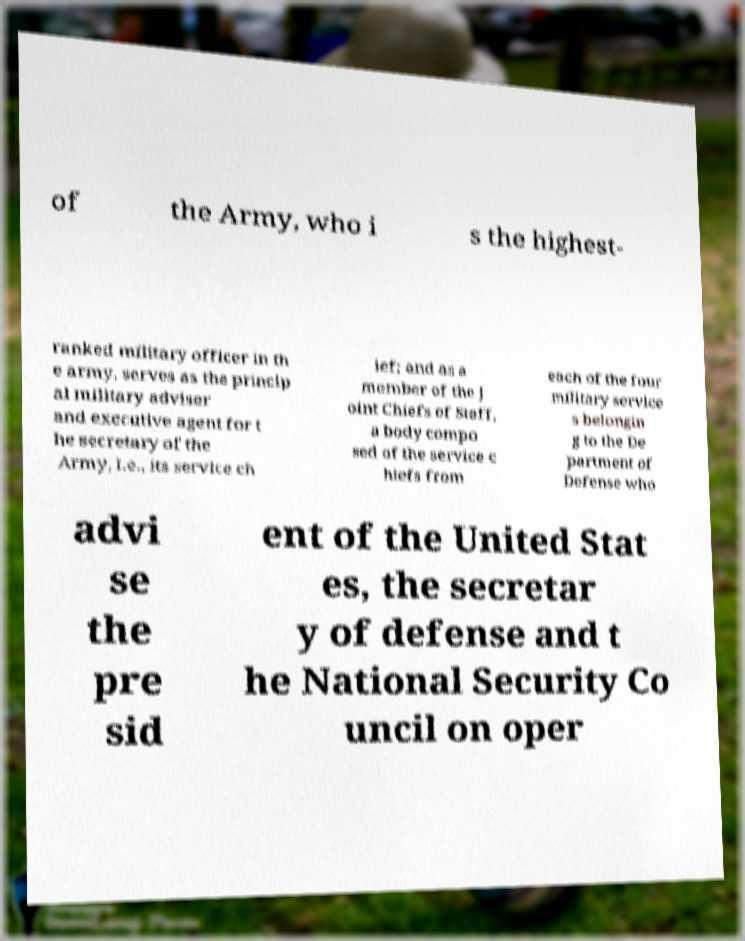Could you extract and type out the text from this image? of the Army, who i s the highest- ranked military officer in th e army, serves as the princip al military adviser and executive agent for t he secretary of the Army, i.e., its service ch ief; and as a member of the J oint Chiefs of Staff, a body compo sed of the service c hiefs from each of the four military service s belongin g to the De partment of Defense who advi se the pre sid ent of the United Stat es, the secretar y of defense and t he National Security Co uncil on oper 